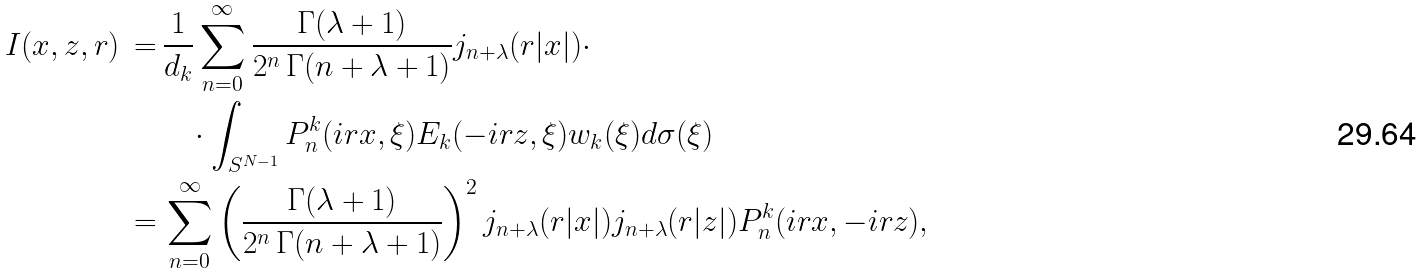<formula> <loc_0><loc_0><loc_500><loc_500>I ( x , z , r ) \, = & \, \frac { 1 } { d _ { k } } \sum _ { n = 0 } ^ { \infty } \frac { \Gamma ( \lambda + 1 ) } { 2 ^ { n } \, \Gamma ( n + \lambda + 1 ) } j _ { n + \lambda } ( r | x | ) \cdot \\ & \quad \cdot \int _ { S ^ { N - 1 } } P _ { n } ^ { k } ( i r x , \xi ) E _ { k } ( - i r z , \xi ) w _ { k } ( \xi ) d \sigma ( \xi ) \\ = & \, \sum _ { n = 0 } ^ { \infty } \left ( \frac { \Gamma ( \lambda + 1 ) } { 2 ^ { n } \, \Gamma ( n + \lambda + 1 ) } \right ) ^ { 2 } j _ { n + \lambda } ( r | x | ) j _ { n + \lambda } ( r | z | ) P _ { n } ^ { k } ( i r x , - i r z ) ,</formula> 